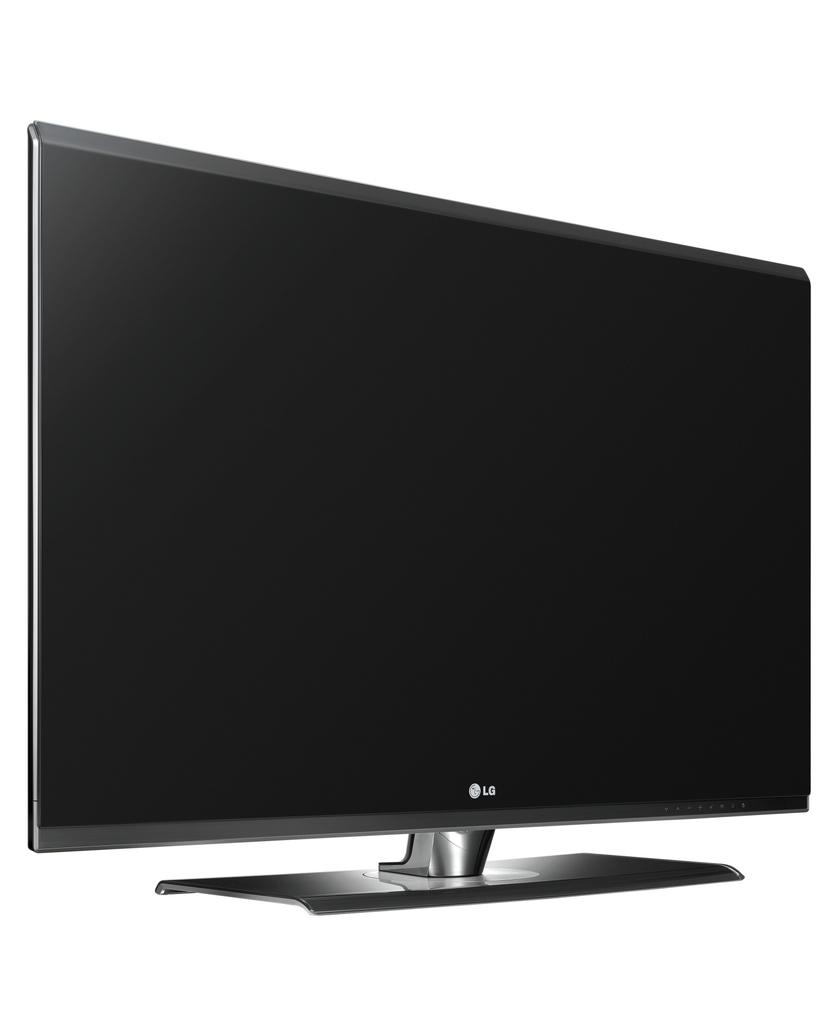<image>
Relay a brief, clear account of the picture shown. An LG TV set against a pure white background. 